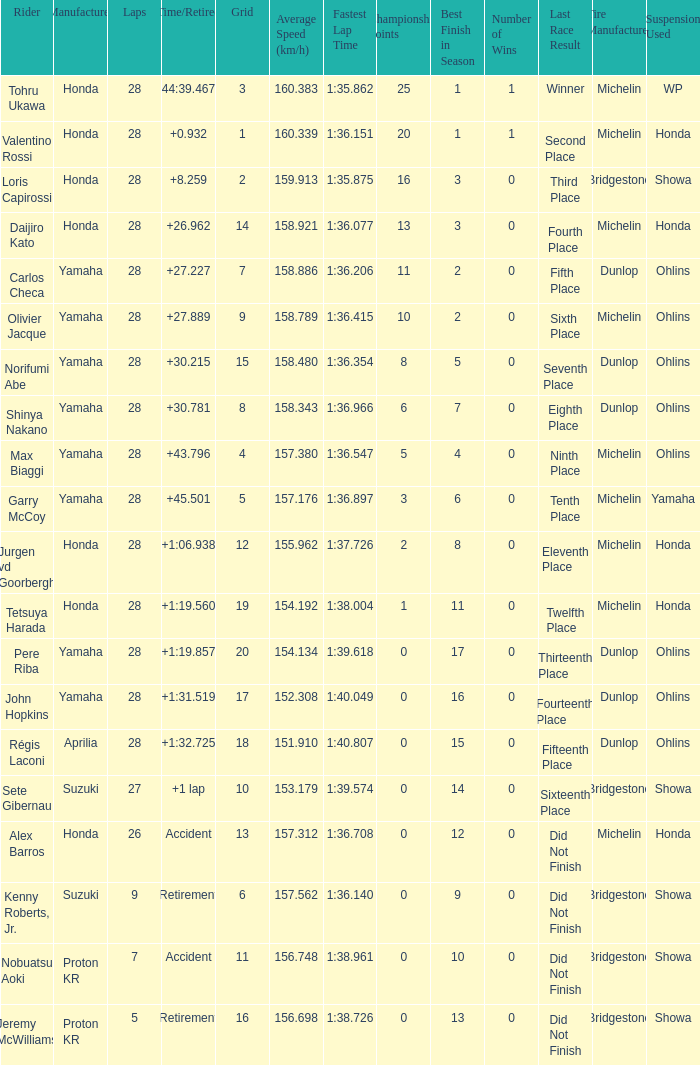In which grid do the laps exceed 26 and have a time/retired of 44:39.467? 3.0. Could you help me parse every detail presented in this table? {'header': ['Rider', 'Manufacturer', 'Laps', 'Time/Retired', 'Grid', 'Average Speed (km/h)', 'Fastest Lap Time', 'Championship Points', 'Best Finish in Season', 'Number of Wins', 'Last Race Result', 'Tire Manufacturer', 'Suspension Used '], 'rows': [['Tohru Ukawa', 'Honda', '28', '44:39.467', '3', '160.383', '1:35.862', '25', '1', '1', 'Winner', 'Michelin', 'WP'], ['Valentino Rossi', 'Honda', '28', '+0.932', '1', '160.339', '1:36.151', '20', '1', '1', 'Second Place', 'Michelin', 'Honda'], ['Loris Capirossi', 'Honda', '28', '+8.259', '2', '159.913', '1:35.875', '16', '3', '0', 'Third Place', 'Bridgestone', 'Showa'], ['Daijiro Kato', 'Honda', '28', '+26.962', '14', '158.921', '1:36.077', '13', '3', '0', 'Fourth Place', 'Michelin', 'Honda'], ['Carlos Checa', 'Yamaha', '28', '+27.227', '7', '158.886', '1:36.206', '11', '2', '0', 'Fifth Place', 'Dunlop', 'Ohlins'], ['Olivier Jacque', 'Yamaha', '28', '+27.889', '9', '158.789', '1:36.415', '10', '2', '0', 'Sixth Place', 'Michelin', 'Ohlins'], ['Norifumi Abe', 'Yamaha', '28', '+30.215', '15', '158.480', '1:36.354', '8', '5', '0', 'Seventh Place', 'Dunlop', 'Ohlins'], ['Shinya Nakano', 'Yamaha', '28', '+30.781', '8', '158.343', '1:36.966', '6', '7', '0', 'Eighth Place', 'Dunlop', 'Ohlins'], ['Max Biaggi', 'Yamaha', '28', '+43.796', '4', '157.380', '1:36.547', '5', '4', '0', 'Ninth Place', 'Michelin', 'Ohlins'], ['Garry McCoy', 'Yamaha', '28', '+45.501', '5', '157.176', '1:36.897', '3', '6', '0', 'Tenth Place', 'Michelin', 'Yamaha'], ['Jurgen vd Goorbergh', 'Honda', '28', '+1:06.938', '12', '155.962', '1:37.726', '2', '8', '0', 'Eleventh Place', 'Michelin', 'Honda'], ['Tetsuya Harada', 'Honda', '28', '+1:19.560', '19', '154.192', '1:38.004', '1', '11', '0', 'Twelfth Place', 'Michelin', 'Honda'], ['Pere Riba', 'Yamaha', '28', '+1:19.857', '20', '154.134', '1:39.618', '0', '17', '0', 'Thirteenth Place', 'Dunlop', 'Ohlins'], ['John Hopkins', 'Yamaha', '28', '+1:31.519', '17', '152.308', '1:40.049', '0', '16', '0', 'Fourteenth Place', 'Dunlop', 'Ohlins'], ['Régis Laconi', 'Aprilia', '28', '+1:32.725', '18', '151.910', '1:40.807', '0', '15', '0', 'Fifteenth Place', 'Dunlop', 'Ohlins'], ['Sete Gibernau', 'Suzuki', '27', '+1 lap', '10', '153.179', '1:39.574', '0', '14', '0', 'Sixteenth Place', 'Bridgestone', 'Showa'], ['Alex Barros', 'Honda', '26', 'Accident', '13', '157.312', '1:36.708', '0', '12', '0', 'Did Not Finish', 'Michelin', 'Honda'], ['Kenny Roberts, Jr.', 'Suzuki', '9', 'Retirement', '6', '157.562', '1:36.140', '0', '9', '0', 'Did Not Finish', 'Bridgestone', 'Showa'], ['Nobuatsu Aoki', 'Proton KR', '7', 'Accident', '11', '156.748', '1:38.961', '0', '10', '0', 'Did Not Finish', 'Bridgestone', 'Showa'], ['Jeremy McWilliams', 'Proton KR', '5', 'Retirement', '16', '156.698', '1:38.726', '0', '13', '0', 'Did Not Finish', 'Bridgestone', 'Showa']]} 